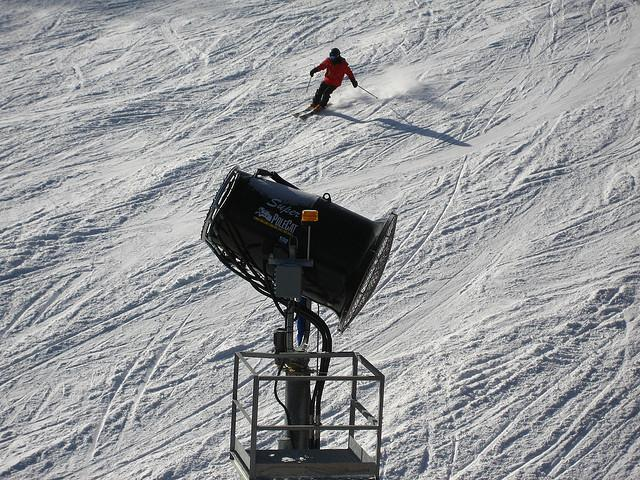What is the person in the jacket holding?

Choices:
A) basket
B) kittens
C) eggs
D) skis skis 